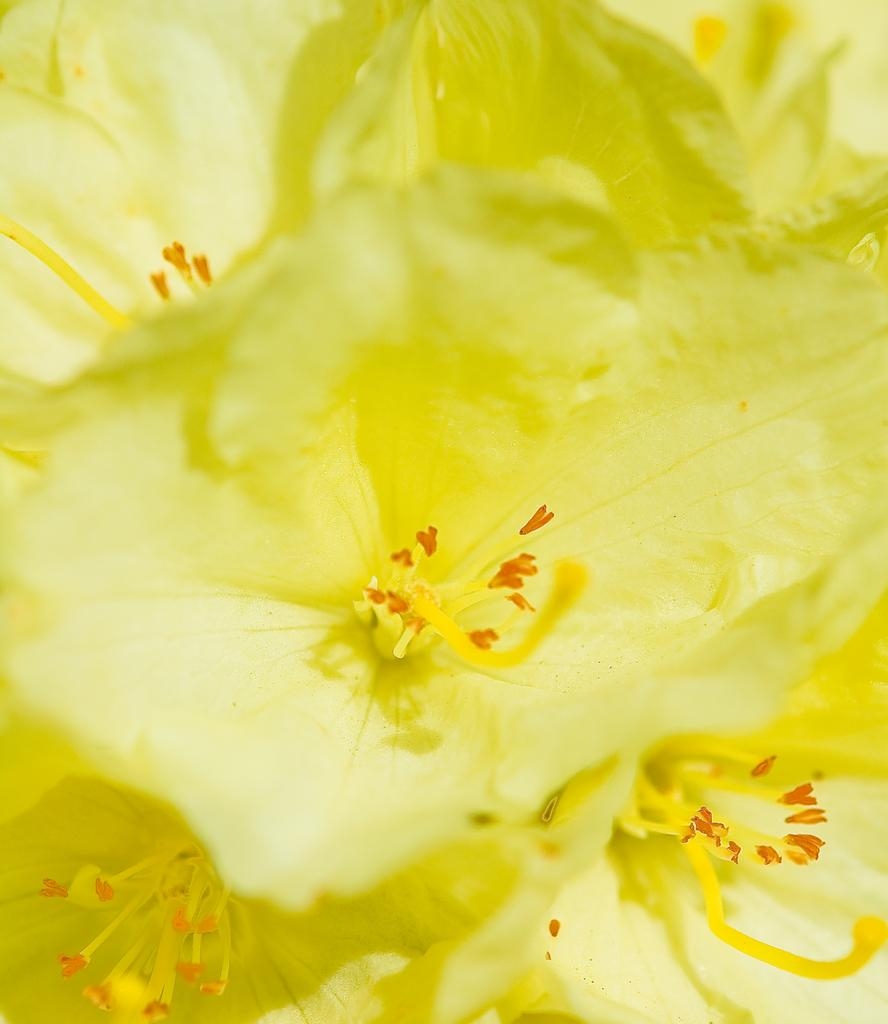What type of flowers are present in the image? There are yellow flowers in the image. Can you describe the center of the flowers? The center of the flowers contains anthers. What type of ornament is hanging from the edge of the flowers in the image? There is no ornament present in the image; it only features yellow flowers with anthers in the center. 